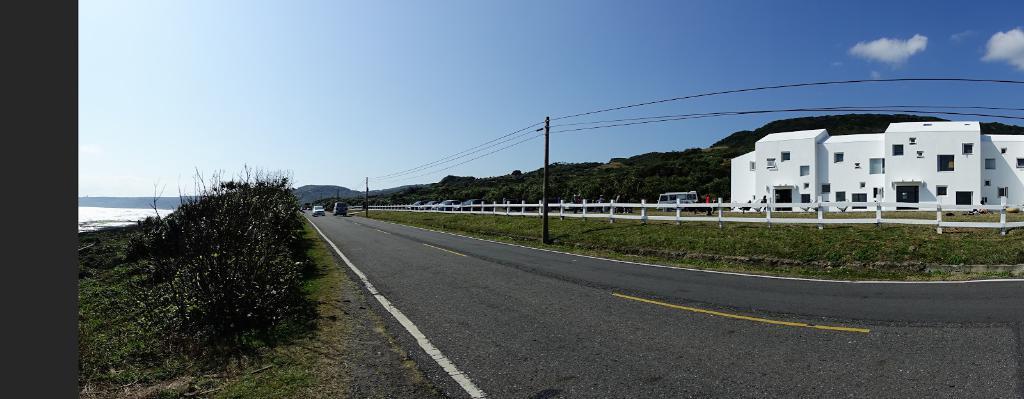In one or two sentences, can you explain what this image depicts? In this picture we can see few poles, fence and vehicles, in the background we can find a building, few trees, group of people and clouds, on the left side of the image we can see water. 